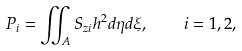<formula> <loc_0><loc_0><loc_500><loc_500>P _ { i } = \iint _ { A } S _ { z i } h ^ { 2 } d \eta d \xi , \quad i = 1 , 2 ,</formula> 